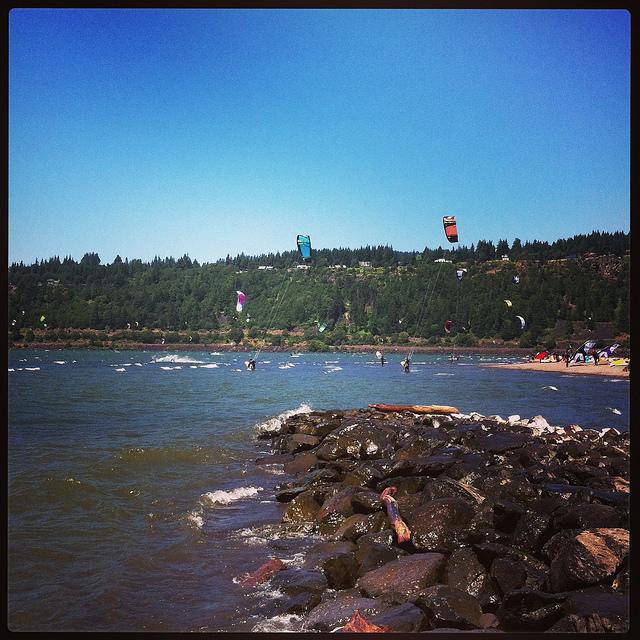Is this an ocean?
Give a very brief answer. Yes. Are there clouds visible?
Quick response, please. No. Is the water calm?
Be succinct. No. Is this a swimming pool?
Concise answer only. No. Is this a black and white or color photo?
Answer briefly. Color. Is it cloudy?
Be succinct. No. Is this picture in color?
Write a very short answer. Yes. Is this a recent photograph?
Be succinct. Yes. What animals are in the water?
Quick response, please. Fish. Is this a romantic scene?
Keep it brief. No. What is the name of the pattern appearing on top of the picture?
Give a very brief answer. None. Is there a sandy beach in the horizon?
Short answer required. Yes. What is jutting out of the water in the foreground?
Concise answer only. Rocks. IS there any boats in the water?
Write a very short answer. No. Is the sky clear?
Quick response, please. Yes. What is the yellow object in the water?
Give a very brief answer. Boat. How many parasailers are there?
Short answer required. 3. 